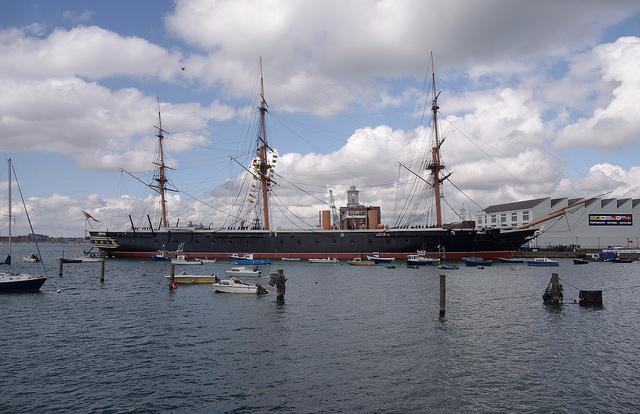What mode of transport is in the above picture? Please explain your reasoning. water. Boats can currently only travel on water. 